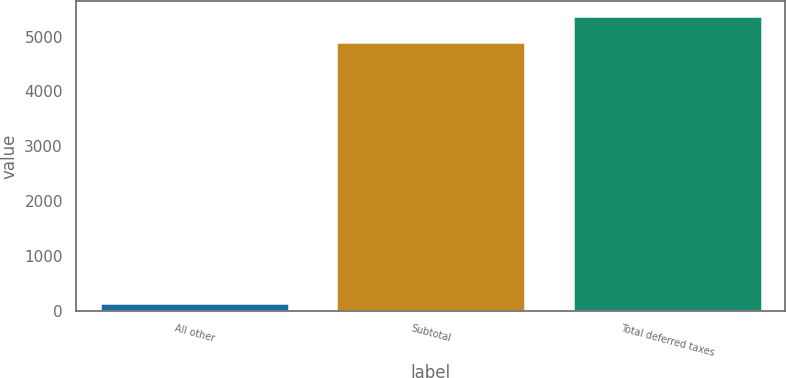<chart> <loc_0><loc_0><loc_500><loc_500><bar_chart><fcel>All other<fcel>Subtotal<fcel>Total deferred taxes<nl><fcel>131<fcel>4897<fcel>5373.6<nl></chart> 